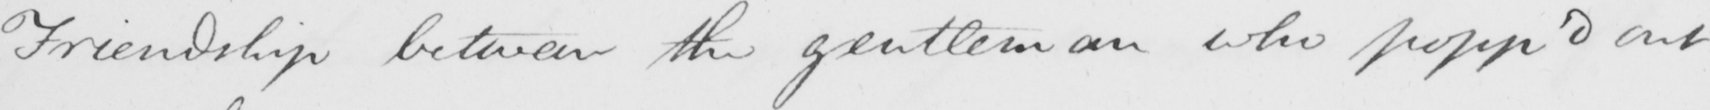What text is written in this handwritten line? Friendship between the gentleman who popp ' d out 